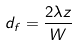Convert formula to latex. <formula><loc_0><loc_0><loc_500><loc_500>d _ { f } = \frac { 2 \lambda z } { W }</formula> 